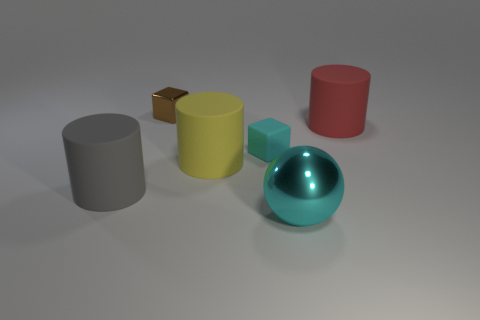There is a block that is the same color as the ball; what is its size? The block sharing the same teal color as the ball appears to be medium in size relative to other objects in the image, such as the smaller yellow block and the larger red cylinder. 